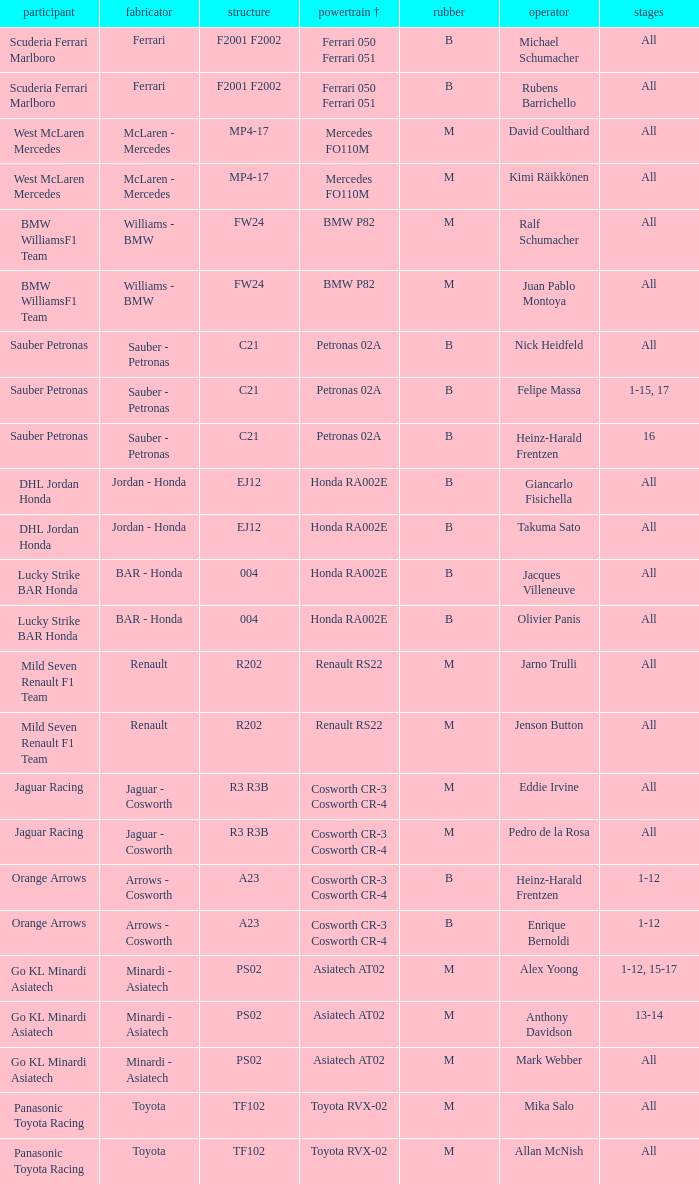What is the engine when the rounds ar all, the tyre is m and the driver is david coulthard? Mercedes FO110M. 